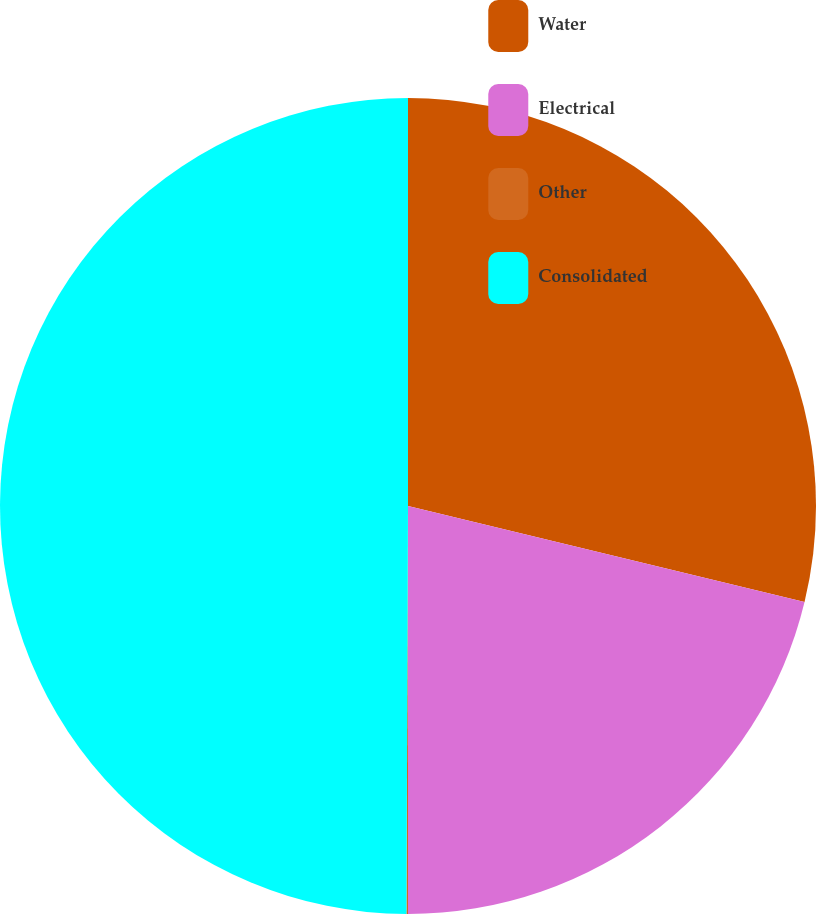Convert chart to OTSL. <chart><loc_0><loc_0><loc_500><loc_500><pie_chart><fcel>Water<fcel>Electrical<fcel>Other<fcel>Consolidated<nl><fcel>28.78%<fcel>21.22%<fcel>0.06%<fcel>49.94%<nl></chart> 